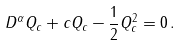<formula> <loc_0><loc_0><loc_500><loc_500>D ^ { \alpha } Q _ { c } + c Q _ { c } - \frac { 1 } { 2 } Q _ { c } ^ { 2 } = 0 \, .</formula> 